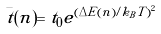<formula> <loc_0><loc_0><loc_500><loc_500>\bar { t } ( n ) = t _ { 0 } e ^ { ( \Delta E ( n ) / k _ { B } T ) ^ { 2 } }</formula> 